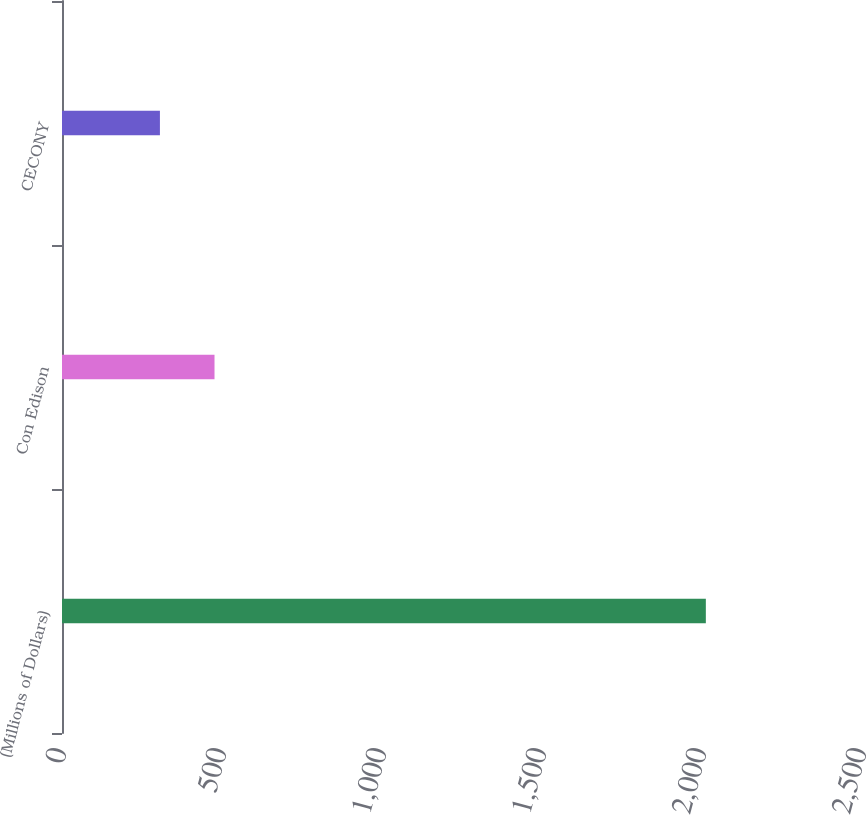Convert chart. <chart><loc_0><loc_0><loc_500><loc_500><bar_chart><fcel>(Millions of Dollars)<fcel>Con Edison<fcel>CECONY<nl><fcel>2012<fcel>476.6<fcel>306<nl></chart> 